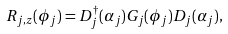<formula> <loc_0><loc_0><loc_500><loc_500>R _ { j , z } ( \phi _ { j } ) = D _ { j } ^ { \dagger } ( \alpha _ { j } ) G _ { j } ( \phi _ { j } ) D _ { j } ( \alpha _ { j } ) ,</formula> 